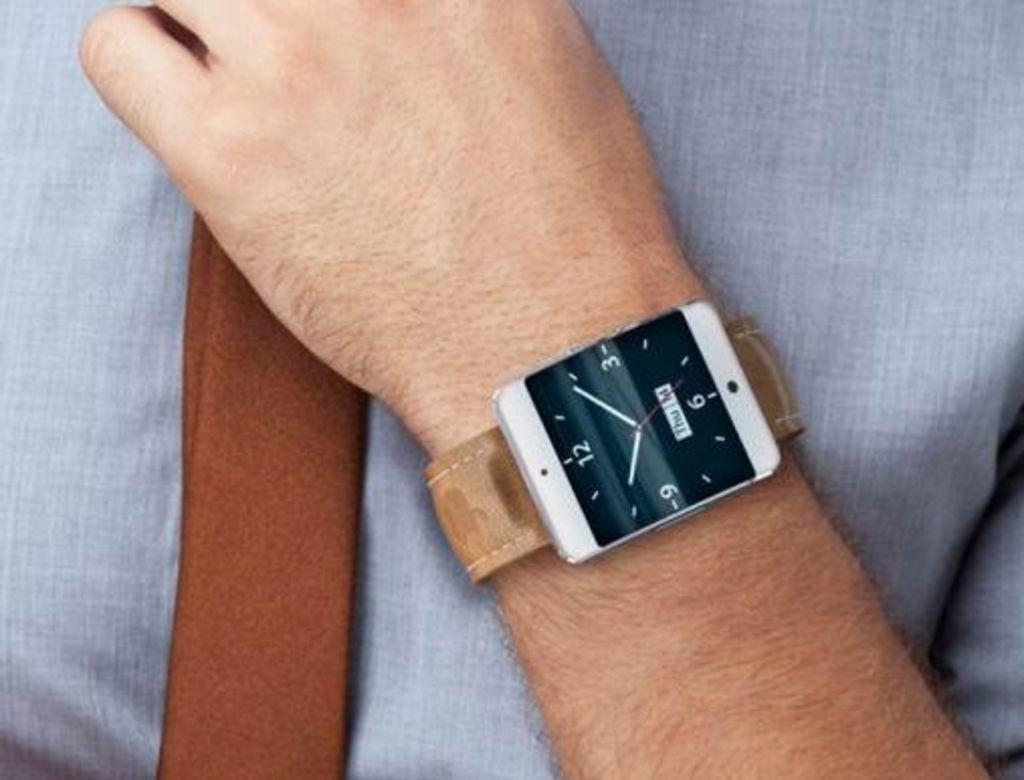<image>
Provide a brief description of the given image. A wrist watch with the number 12 visible on it. 